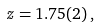<formula> <loc_0><loc_0><loc_500><loc_500>z = 1 . 7 5 ( 2 ) \, ,</formula> 